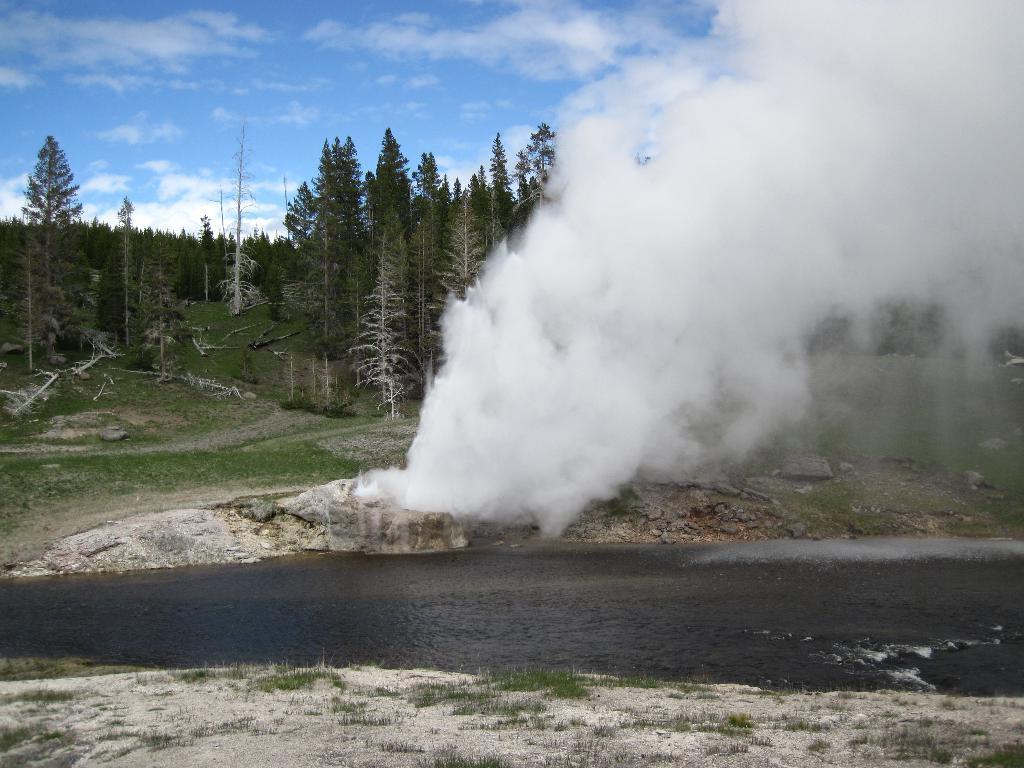How would you summarize this image in a sentence or two? In this picture we can observe a lake flowing. There is some grass on the land. We can observe white color smoke here. In the background there are trees and a sky with some clouds. 